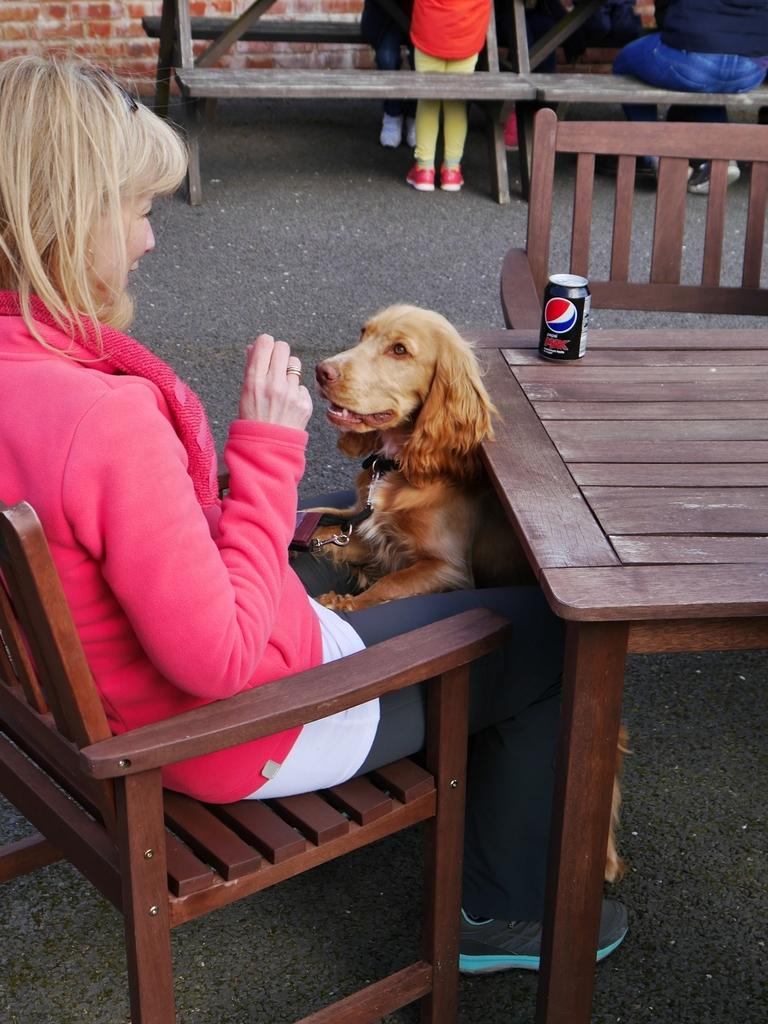What is the woman doing in the image? The woman is sitting in a chair. What is in front of the woman? There is a dog in front of the woman. What can be seen on the table in the image? There is a Coke tin on a table. What is the name of the club where the woman and the dog are dancing in the image? There is no club or dancing present in the image; the woman is sitting in a chair and the dog is in front of her. 